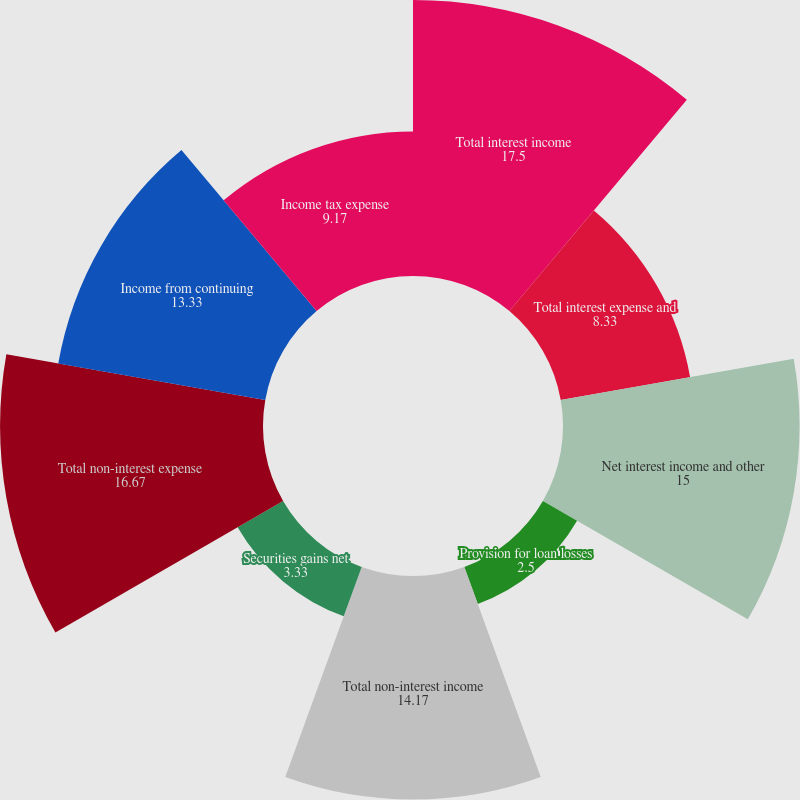<chart> <loc_0><loc_0><loc_500><loc_500><pie_chart><fcel>Total interest income<fcel>Total interest expense and<fcel>Net interest income and other<fcel>Provision for loan losses<fcel>Total non-interest income<fcel>Securities gains net<fcel>Total non-interest expense<fcel>Income from continuing<fcel>Income tax expense<nl><fcel>17.5%<fcel>8.33%<fcel>15.0%<fcel>2.5%<fcel>14.17%<fcel>3.33%<fcel>16.67%<fcel>13.33%<fcel>9.17%<nl></chart> 